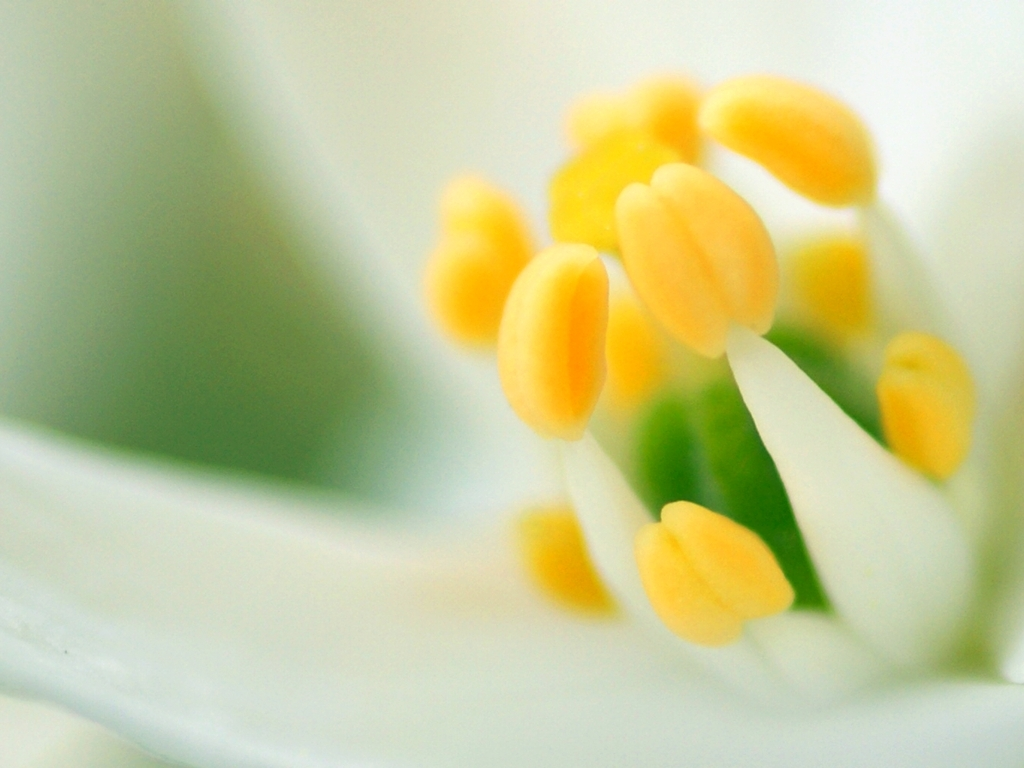Could you tell me more about the composition of this photograph? Certainly! The photographer has used a macro lens or a close-up technique to isolate the stamens of the flower, creating a shallow depth of field. This draws the viewer's attention to the vibrant yellow anthers while the blurred white petals provide a soft, ethereal backdrop, emphasizing the delicacy and beauty of the floral subject. 